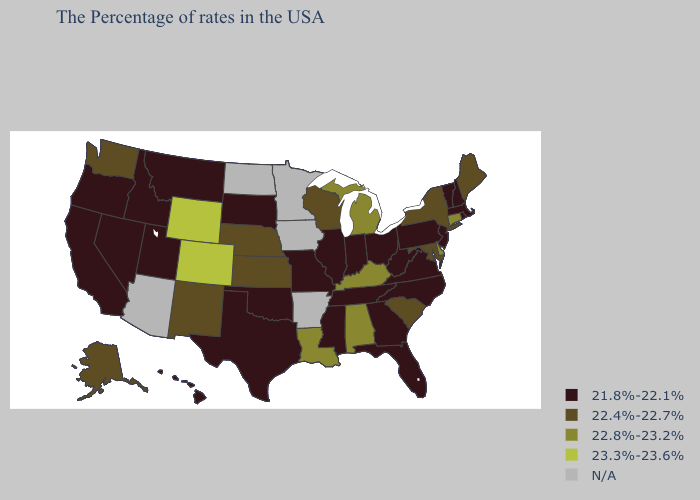What is the value of New Mexico?
Concise answer only. 22.4%-22.7%. Name the states that have a value in the range 23.3%-23.6%?
Short answer required. Wyoming, Colorado. Does Alaska have the lowest value in the West?
Be succinct. No. Does Missouri have the lowest value in the MidWest?
Concise answer only. Yes. Does Nevada have the highest value in the USA?
Concise answer only. No. What is the highest value in the West ?
Quick response, please. 23.3%-23.6%. Is the legend a continuous bar?
Answer briefly. No. What is the value of Indiana?
Be succinct. 21.8%-22.1%. Among the states that border Montana , which have the lowest value?
Keep it brief. South Dakota, Idaho. What is the highest value in states that border Illinois?
Give a very brief answer. 22.8%-23.2%. What is the value of South Carolina?
Write a very short answer. 22.4%-22.7%. Name the states that have a value in the range 22.4%-22.7%?
Be succinct. Maine, New York, Maryland, South Carolina, Wisconsin, Kansas, Nebraska, New Mexico, Washington, Alaska. Does the map have missing data?
Give a very brief answer. Yes. Does the first symbol in the legend represent the smallest category?
Answer briefly. Yes. 